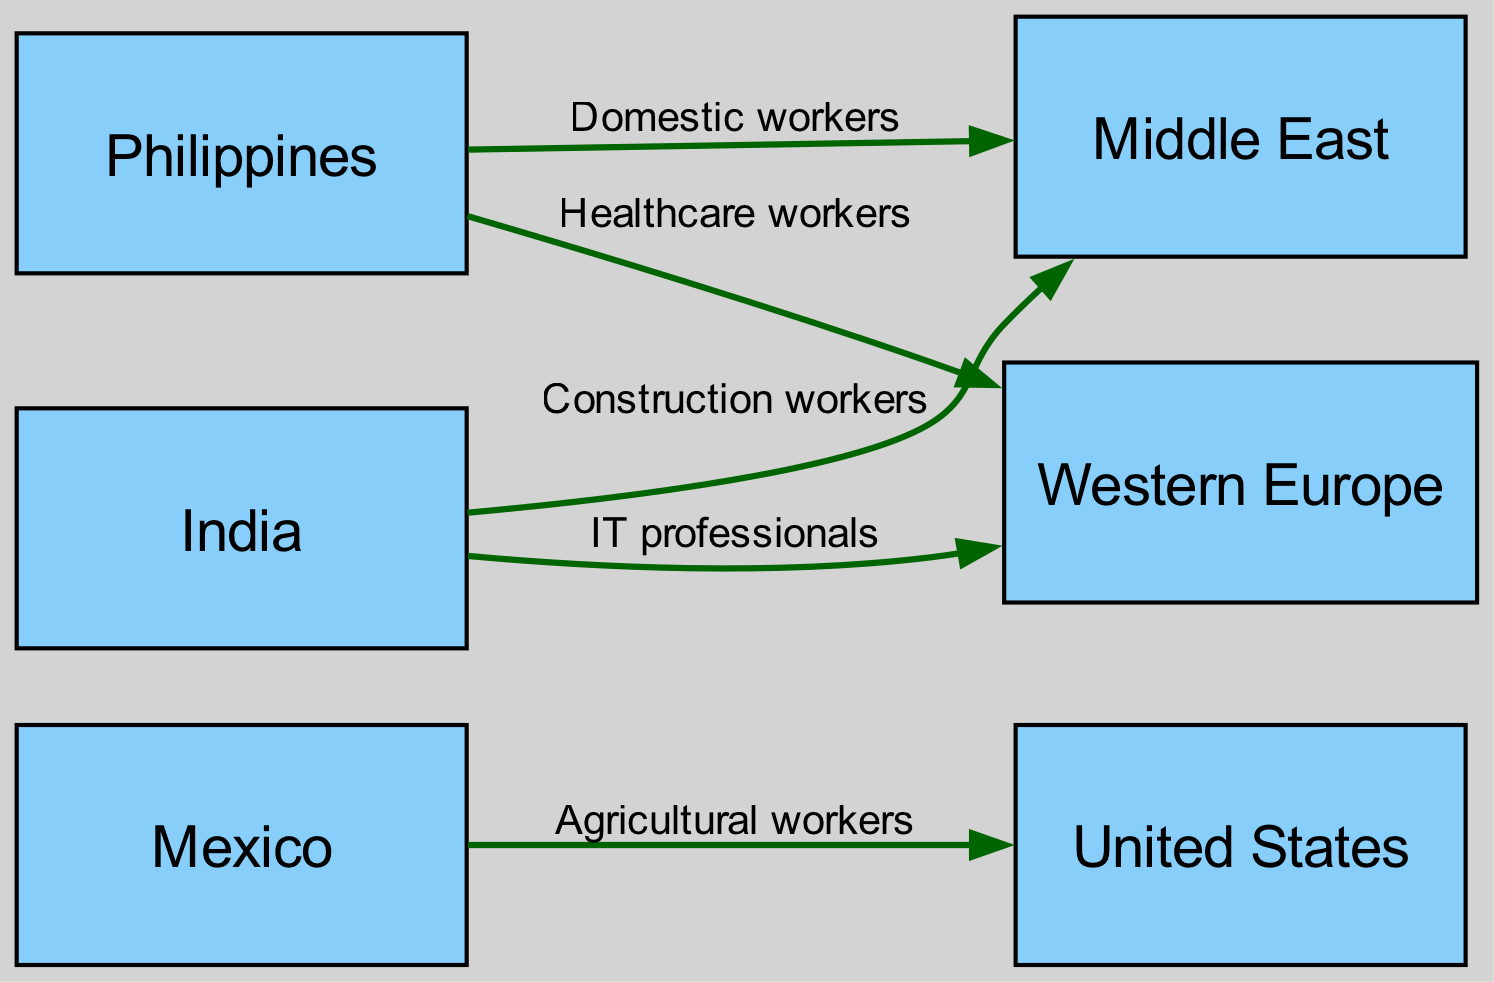What is the total number of nodes in the diagram? The diagram contains a set of distinct locations that represent different countries or regions connected to one another. By counting these nodes, we find that there are 6 in total: Mexico, United States, Philippines, Middle East, India, and Western Europe.
Answer: 6 Which country do agricultural workers migrate from? The edge labeled "Agricultural workers" connects Mexico to the United States, indicating that agricultural workers migrate from Mexico to the United States.
Answer: Mexico What type of workers migrate from the Philippines to the Middle East? The diagram shows an edge connecting the Philippines to the Middle East labeled "Domestic workers," indicating that domestic workers migrate from the Philippines to the Middle East.
Answer: Domestic workers How many types of workers are illustrated in this diagram? By examining the edges, we can identify five distinct types of workers illustrated: Agricultural workers, Domestic workers, Construction workers, Healthcare workers, and IT professionals, which amounts to a total of 5 types.
Answer: 5 Which two countries are connected by a healthcare worker migration? The healthcare workers migrate from the Philippines to Western Europe, as shown by the edge labeled "Healthcare workers," which connects these two locations.
Answer: Philippines and Western Europe What is the migration route for construction workers? The diagram presents an edge connecting India to the Middle East, labeled "Construction workers," indicating that construction workers migrate from India to the Middle East.
Answer: India to Middle East Which country does not have any outgoing worker migration in this diagram? By analyzing the connections in the diagram, we find that the United States does not have any edges leading out of it, indicating that it does not have any outgoing worker migration illustrated.
Answer: United States How is the flow of migration represented in the diagram? The flow of migration is represented by directed edges, where the starting point (source) is shown to the left and points towards the destination (target) on the right, indicating the direction of labor movement.
Answer: Directed edges Which regions have connections to the Middle East? The edges leading to the Middle East show connections from two regions: the Philippines and India, indicating that both these regions have migration routes towards the Middle East.
Answer: Philippines and India 